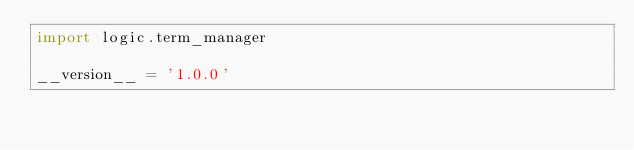<code> <loc_0><loc_0><loc_500><loc_500><_Python_>import logic.term_manager

__version__ = '1.0.0'


</code> 